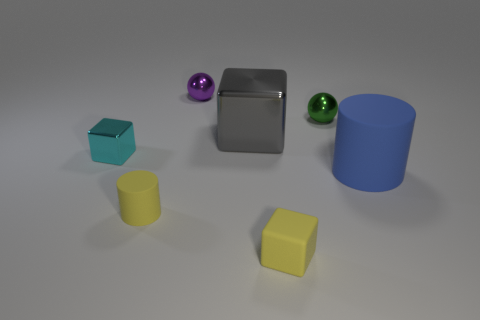Subtract all brown cylinders. Subtract all purple balls. How many cylinders are left? 2 Add 2 large blue metallic cylinders. How many objects exist? 9 Subtract all cylinders. How many objects are left? 5 Add 3 small metal balls. How many small metal balls are left? 5 Add 3 small green rubber objects. How many small green rubber objects exist? 3 Subtract 1 yellow cylinders. How many objects are left? 6 Subtract all gray shiny things. Subtract all cyan objects. How many objects are left? 5 